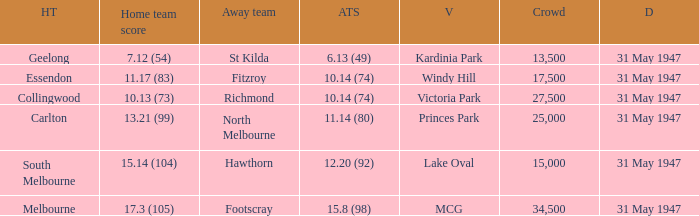What is the home team's score at mcg? 17.3 (105). 